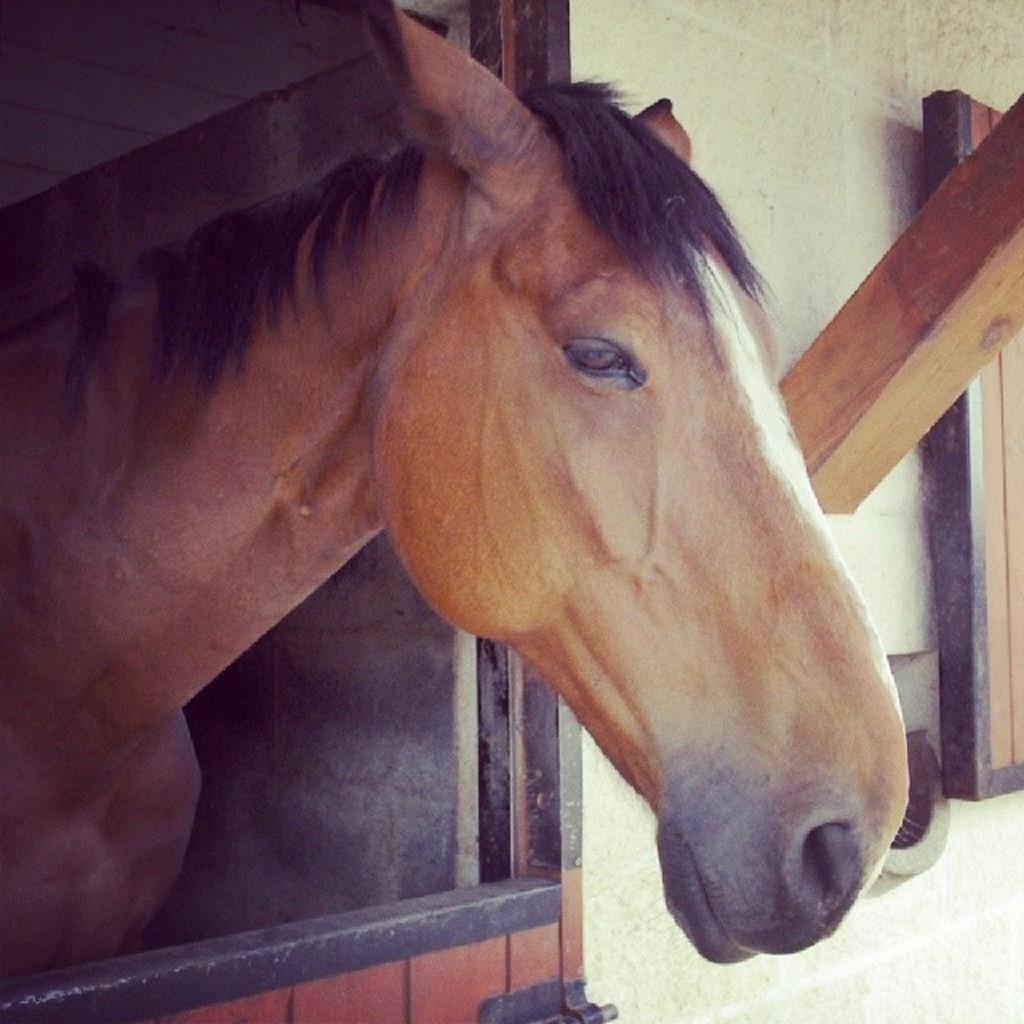Could you give a brief overview of what you see in this image? In this picture there is a horse which is in brown color and there is a wooden object below it and there are few other wooden objects attached to the wall in the right corner. 